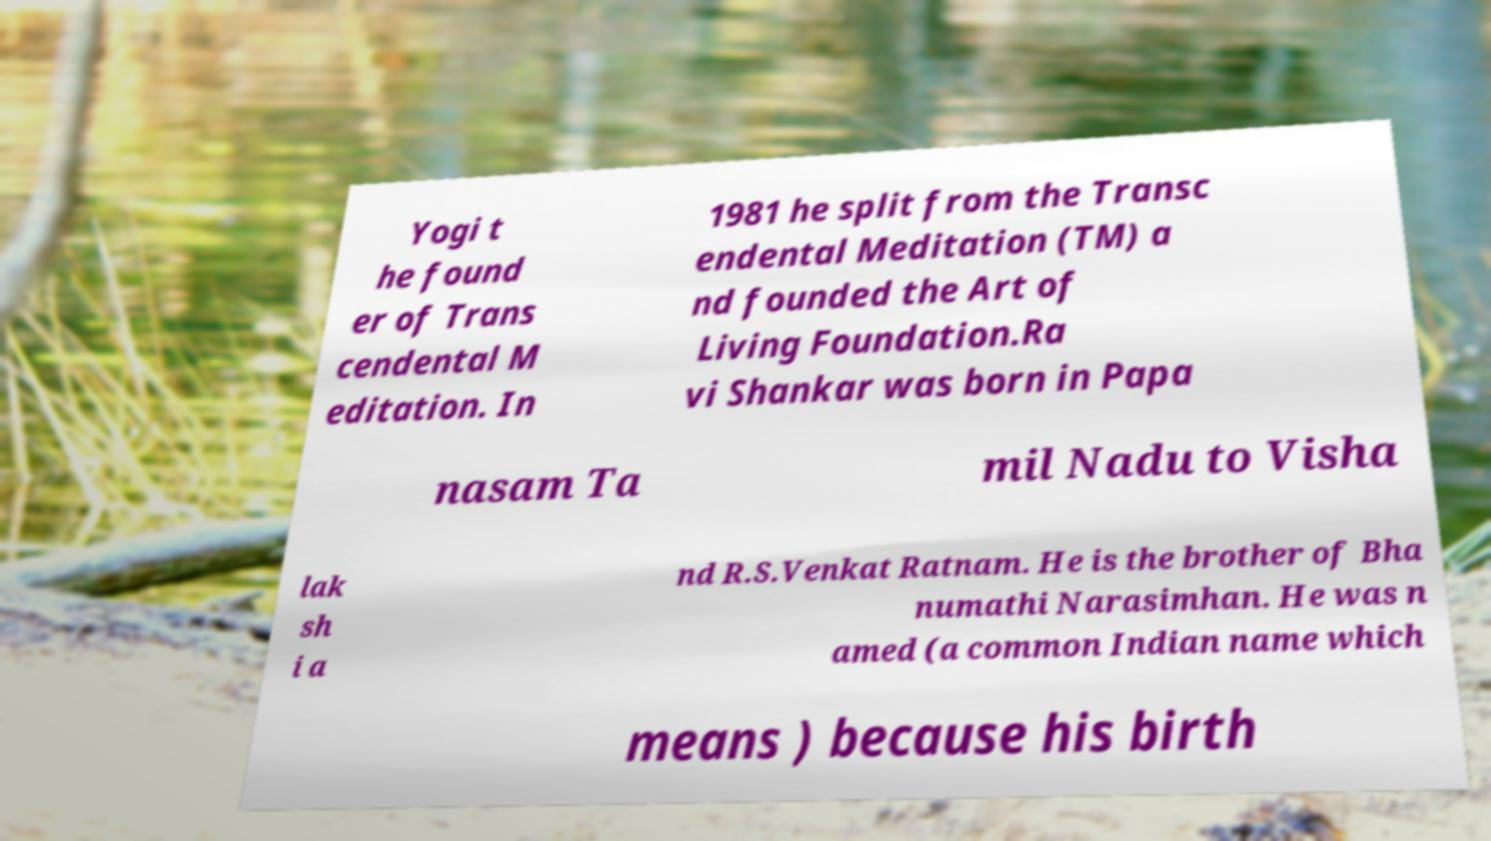Could you extract and type out the text from this image? Yogi t he found er of Trans cendental M editation. In 1981 he split from the Transc endental Meditation (TM) a nd founded the Art of Living Foundation.Ra vi Shankar was born in Papa nasam Ta mil Nadu to Visha lak sh i a nd R.S.Venkat Ratnam. He is the brother of Bha numathi Narasimhan. He was n amed (a common Indian name which means ) because his birth 